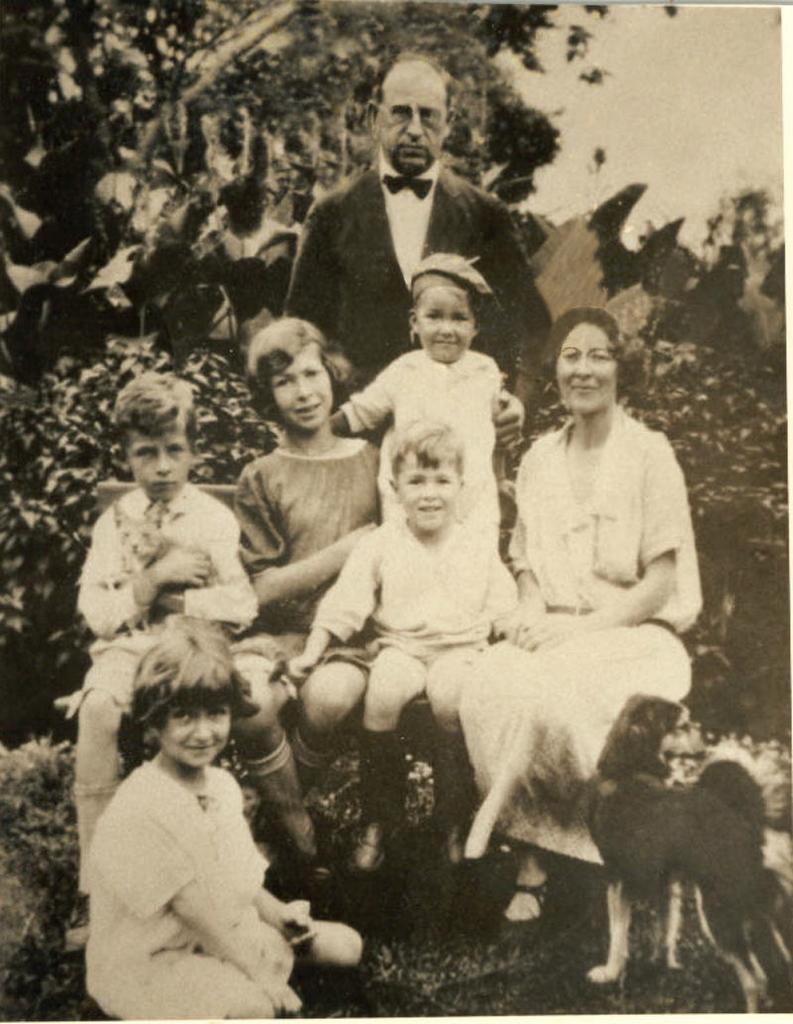Could you give a brief overview of what you see in this image? In this picture we can see group of people, few trees and a dog, and it is a black and white photography. 